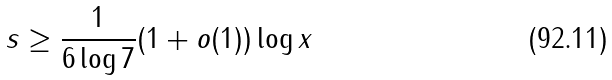<formula> <loc_0><loc_0><loc_500><loc_500>s \geq \frac { 1 } { 6 \log 7 } ( 1 + o ( 1 ) ) \log x</formula> 